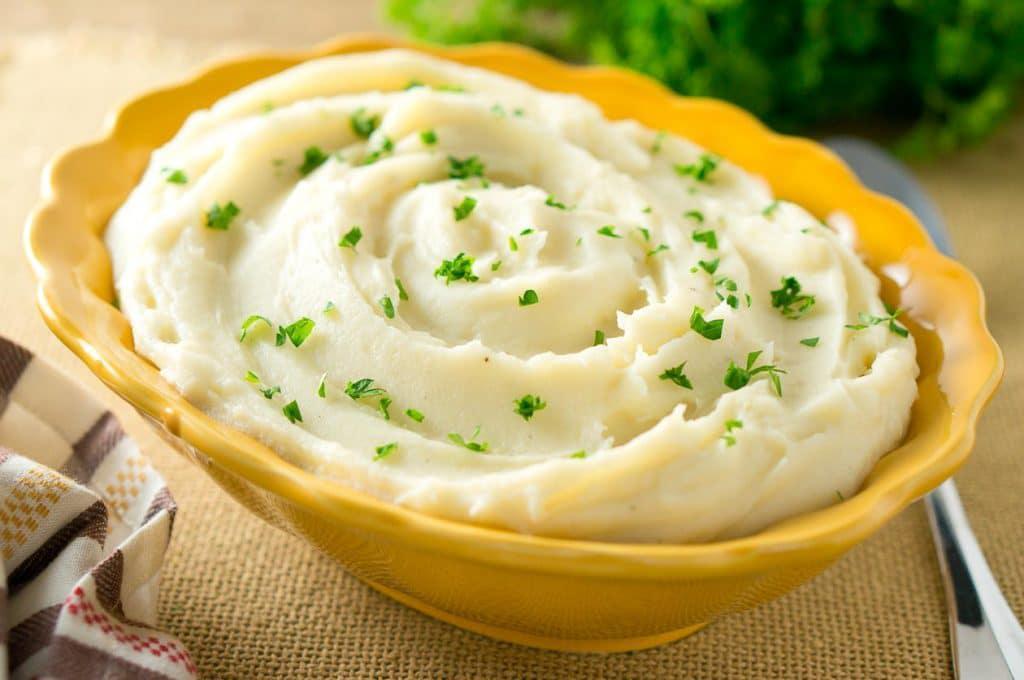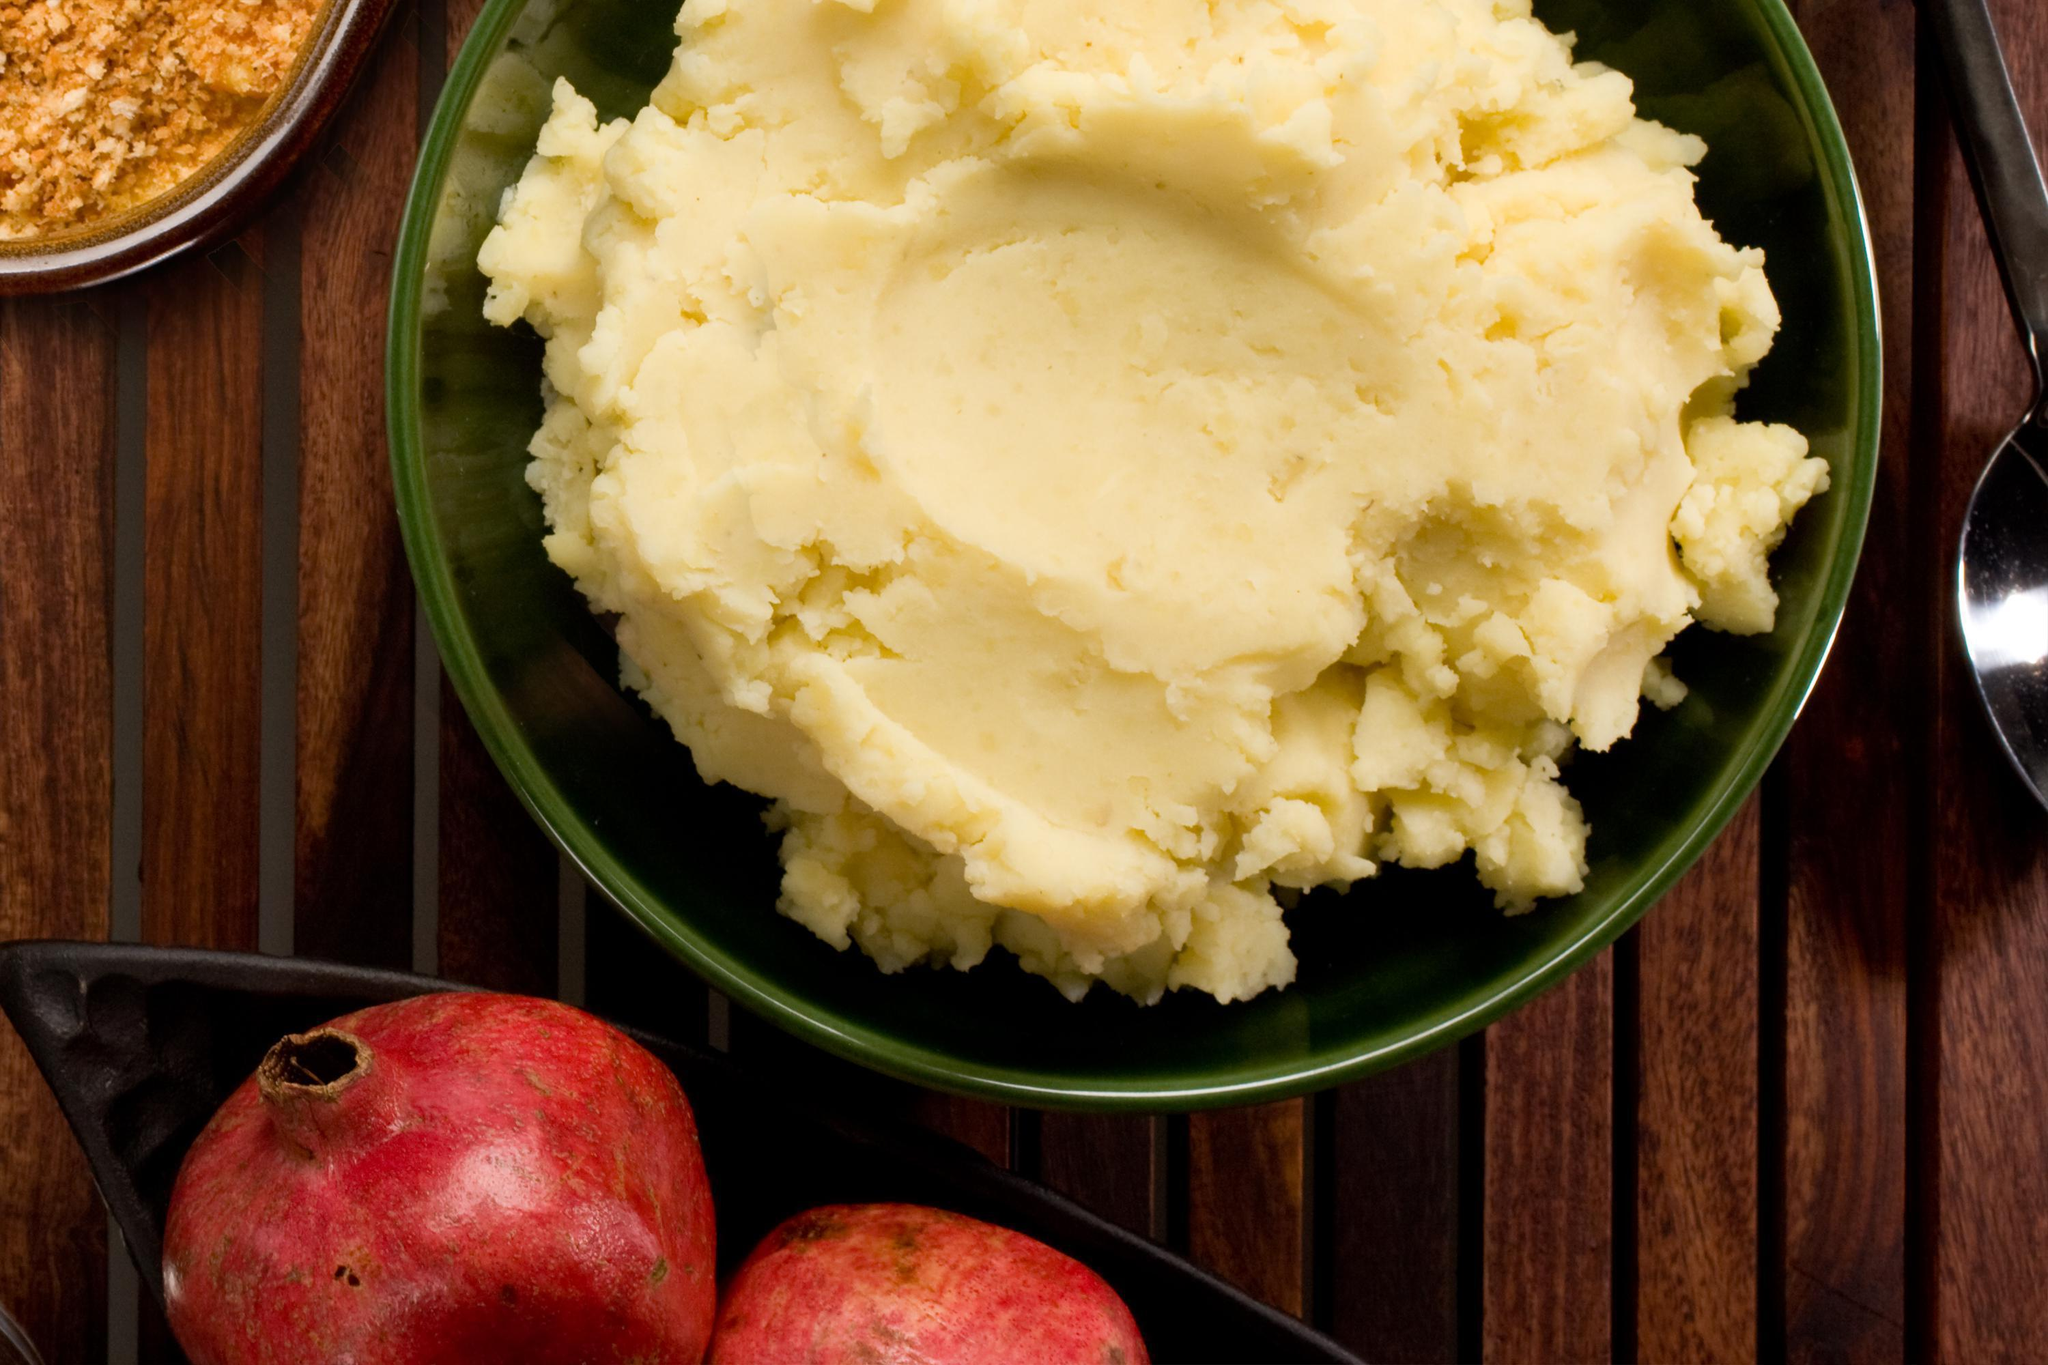The first image is the image on the left, the second image is the image on the right. Examine the images to the left and right. Is the description "In one of the images, there is a green topping." accurate? Answer yes or no. Yes. The first image is the image on the left, the second image is the image on the right. Assess this claim about the two images: "One imagine in the pair has a slab of butter visible in the mashed potato.". Correct or not? Answer yes or no. No. 